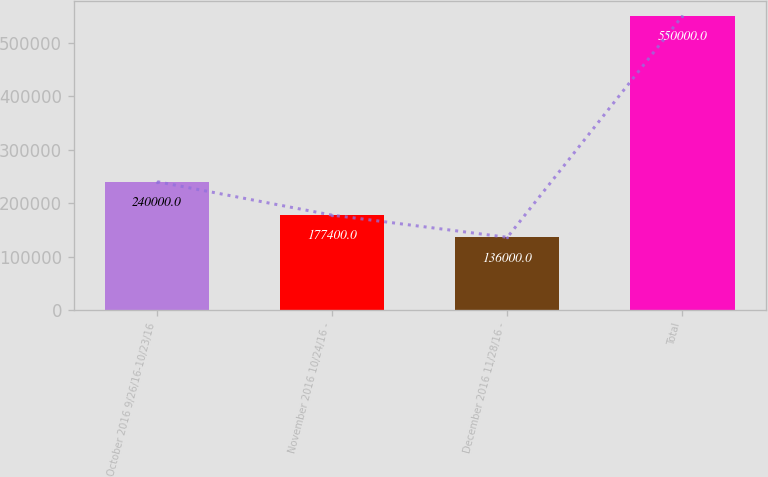<chart> <loc_0><loc_0><loc_500><loc_500><bar_chart><fcel>October 2016 9/26/16-10/23/16<fcel>November 2016 10/24/16 -<fcel>December 2016 11/28/16 -<fcel>Total<nl><fcel>240000<fcel>177400<fcel>136000<fcel>550000<nl></chart> 